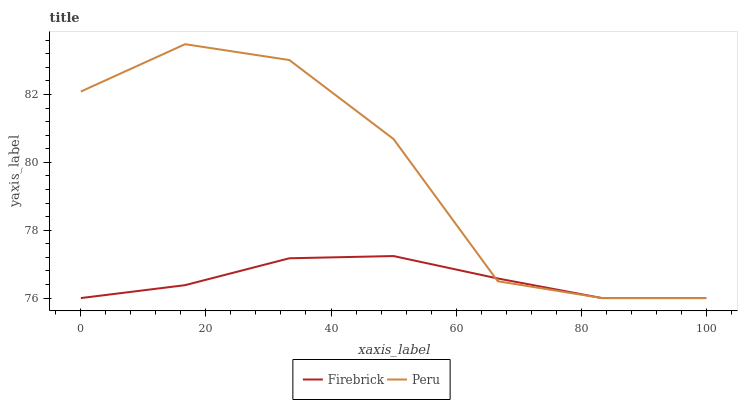Does Firebrick have the minimum area under the curve?
Answer yes or no. Yes. Does Peru have the maximum area under the curve?
Answer yes or no. Yes. Does Peru have the minimum area under the curve?
Answer yes or no. No. Is Firebrick the smoothest?
Answer yes or no. Yes. Is Peru the roughest?
Answer yes or no. Yes. Is Peru the smoothest?
Answer yes or no. No. Does Firebrick have the lowest value?
Answer yes or no. Yes. Does Peru have the highest value?
Answer yes or no. Yes. Does Firebrick intersect Peru?
Answer yes or no. Yes. Is Firebrick less than Peru?
Answer yes or no. No. Is Firebrick greater than Peru?
Answer yes or no. No. 